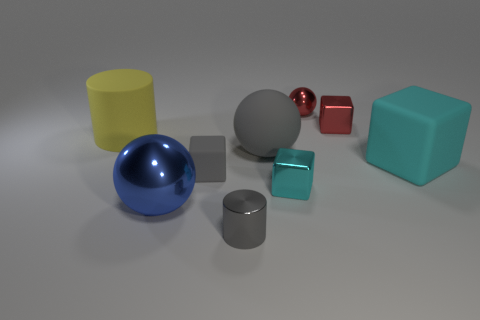Subtract all tiny cubes. How many cubes are left? 1 Subtract all cylinders. How many objects are left? 7 Add 1 large cyan cubes. How many objects exist? 10 Subtract all gray spheres. How many spheres are left? 2 Subtract 2 cylinders. How many cylinders are left? 0 Subtract all yellow spheres. How many yellow cylinders are left? 1 Subtract all blue metal spheres. Subtract all tiny gray metal cylinders. How many objects are left? 7 Add 1 big things. How many big things are left? 5 Add 4 large gray spheres. How many large gray spheres exist? 5 Subtract 0 blue blocks. How many objects are left? 9 